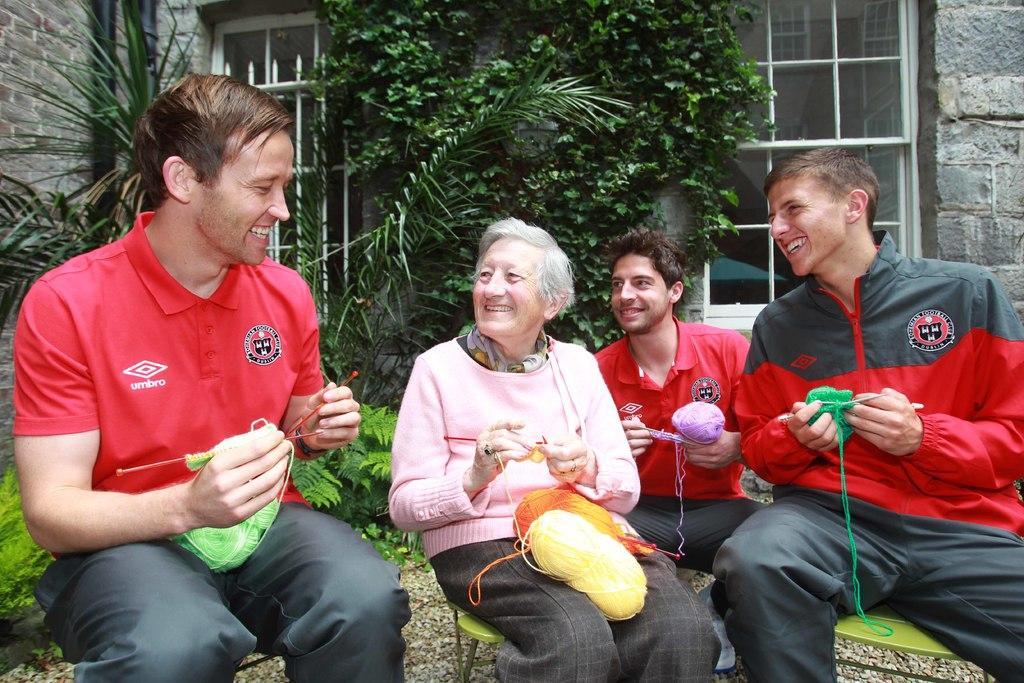Can you describe this image briefly? In this image there are people sitting. We can see wool bundle. There are trees in the background. There is building with stones. There is glass window. 